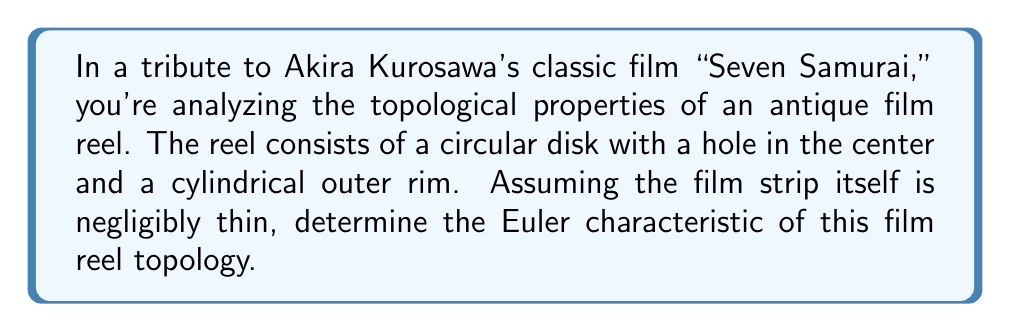What is the answer to this math problem? To determine the Euler characteristic of the film reel topology, we need to consider its fundamental components and use the formula:

$$\chi = V - E + F$$

Where:
$\chi$ is the Euler characteristic
$V$ is the number of vertices
$E$ is the number of edges
$F$ is the number of faces

Let's break down the film reel into its topological components:

1. The circular disk with a hole can be considered as a topological annulus.
2. The cylindrical outer rim is topologically equivalent to a cylinder.

For the annulus:
- It has no vertices: $V_a = 0$
- It has no edges: $E_a = 0$
- It has 1 face: $F_a = 1$

For the cylinder:
- It has no vertices: $V_c = 0$
- It has no edges: $E_c = 0$
- It has 1 face (the curved surface): $F_c = 1$

The cylinder is attached to the annulus along two circular boundaries, which we need to account for:
- These boundaries contribute 2 faces: $F_b = 2$

Now, we can calculate the total components:
$$V = V_a + V_c = 0 + 0 = 0$$
$$E = E_a + E_c = 0 + 0 = 0$$
$$F = F_a + F_c + F_b = 1 + 1 + 2 = 4$$

Applying the Euler characteristic formula:

$$\chi = V - E + F = 0 - 0 + 4 = 4$$

Therefore, the Euler characteristic of the film reel topology is 4.
Answer: $\chi = 4$ 